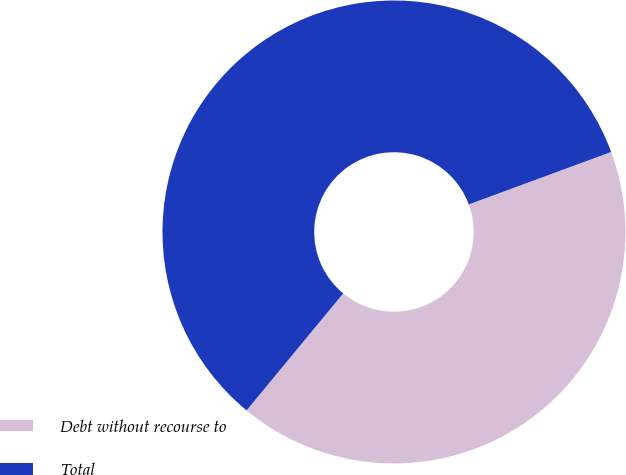Convert chart to OTSL. <chart><loc_0><loc_0><loc_500><loc_500><pie_chart><fcel>Debt without recourse to<fcel>Total<nl><fcel>41.6%<fcel>58.4%<nl></chart> 